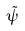<formula> <loc_0><loc_0><loc_500><loc_500>\tilde { \psi }</formula> 